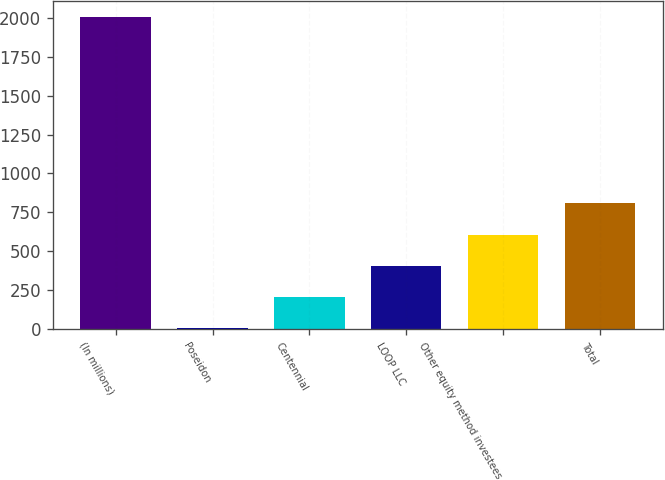Convert chart. <chart><loc_0><loc_0><loc_500><loc_500><bar_chart><fcel>(In millions)<fcel>Poseidon<fcel>Centennial<fcel>LOOP LLC<fcel>Other equity method investees<fcel>Total<nl><fcel>2006<fcel>8<fcel>207.8<fcel>407.6<fcel>607.4<fcel>807.2<nl></chart> 